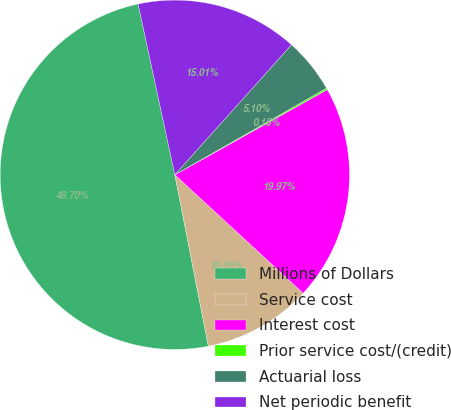Convert chart to OTSL. <chart><loc_0><loc_0><loc_500><loc_500><pie_chart><fcel>Millions of Dollars<fcel>Service cost<fcel>Interest cost<fcel>Prior service cost/(credit)<fcel>Actuarial loss<fcel>Net periodic benefit<nl><fcel>49.7%<fcel>10.06%<fcel>19.97%<fcel>0.15%<fcel>5.1%<fcel>15.01%<nl></chart> 